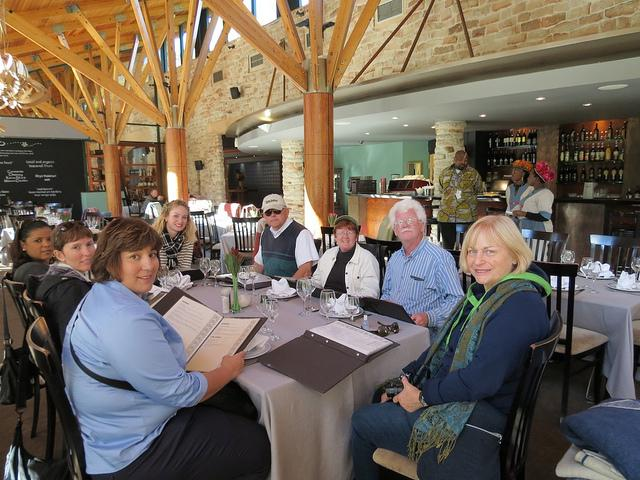What will persons seated here do next? Please explain your reasoning. order. People are ordering. 